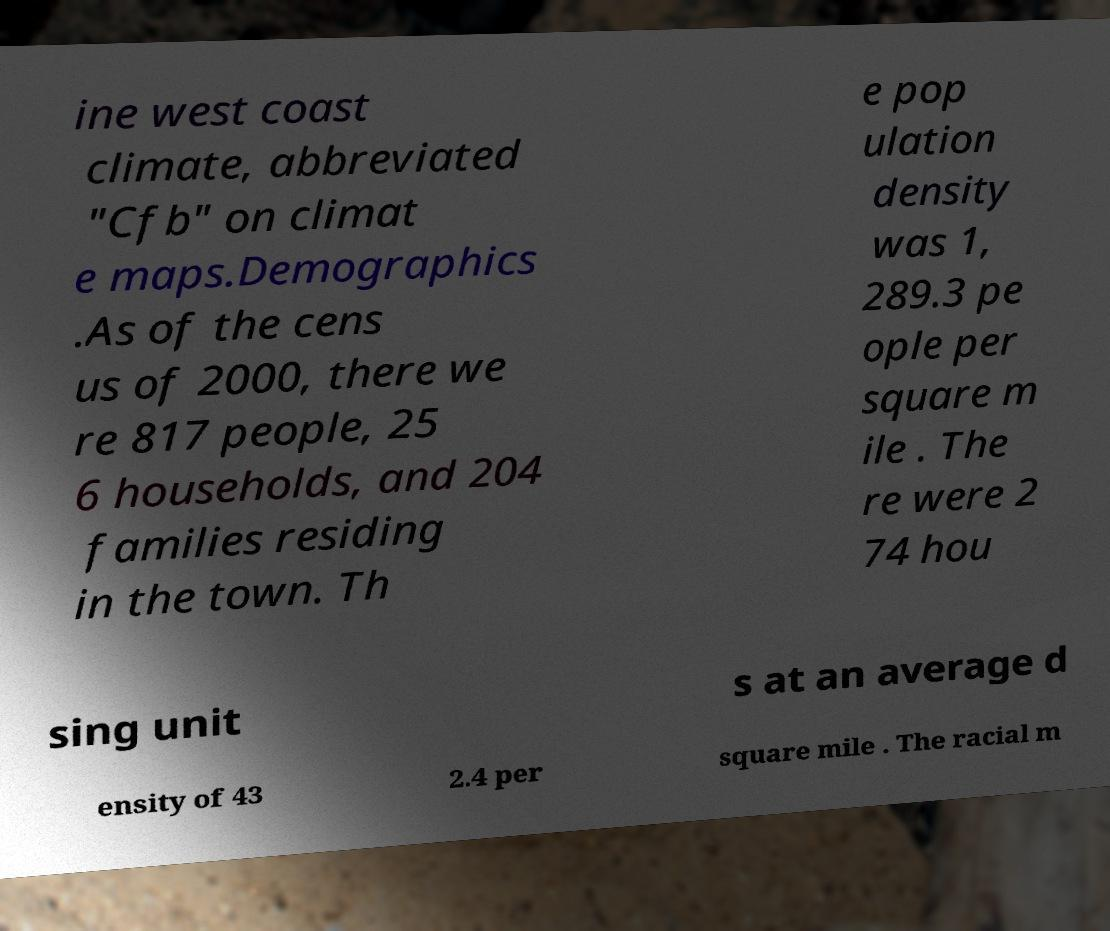Could you assist in decoding the text presented in this image and type it out clearly? ine west coast climate, abbreviated "Cfb" on climat e maps.Demographics .As of the cens us of 2000, there we re 817 people, 25 6 households, and 204 families residing in the town. Th e pop ulation density was 1, 289.3 pe ople per square m ile . The re were 2 74 hou sing unit s at an average d ensity of 43 2.4 per square mile . The racial m 